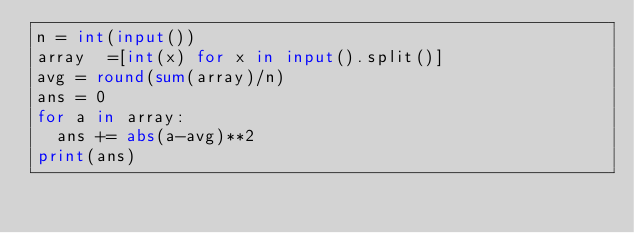Convert code to text. <code><loc_0><loc_0><loc_500><loc_500><_Python_>n = int(input())
array  =[int(x) for x in input().split()]
avg = round(sum(array)/n)
ans = 0
for a in array:
  ans += abs(a-avg)**2
print(ans)</code> 